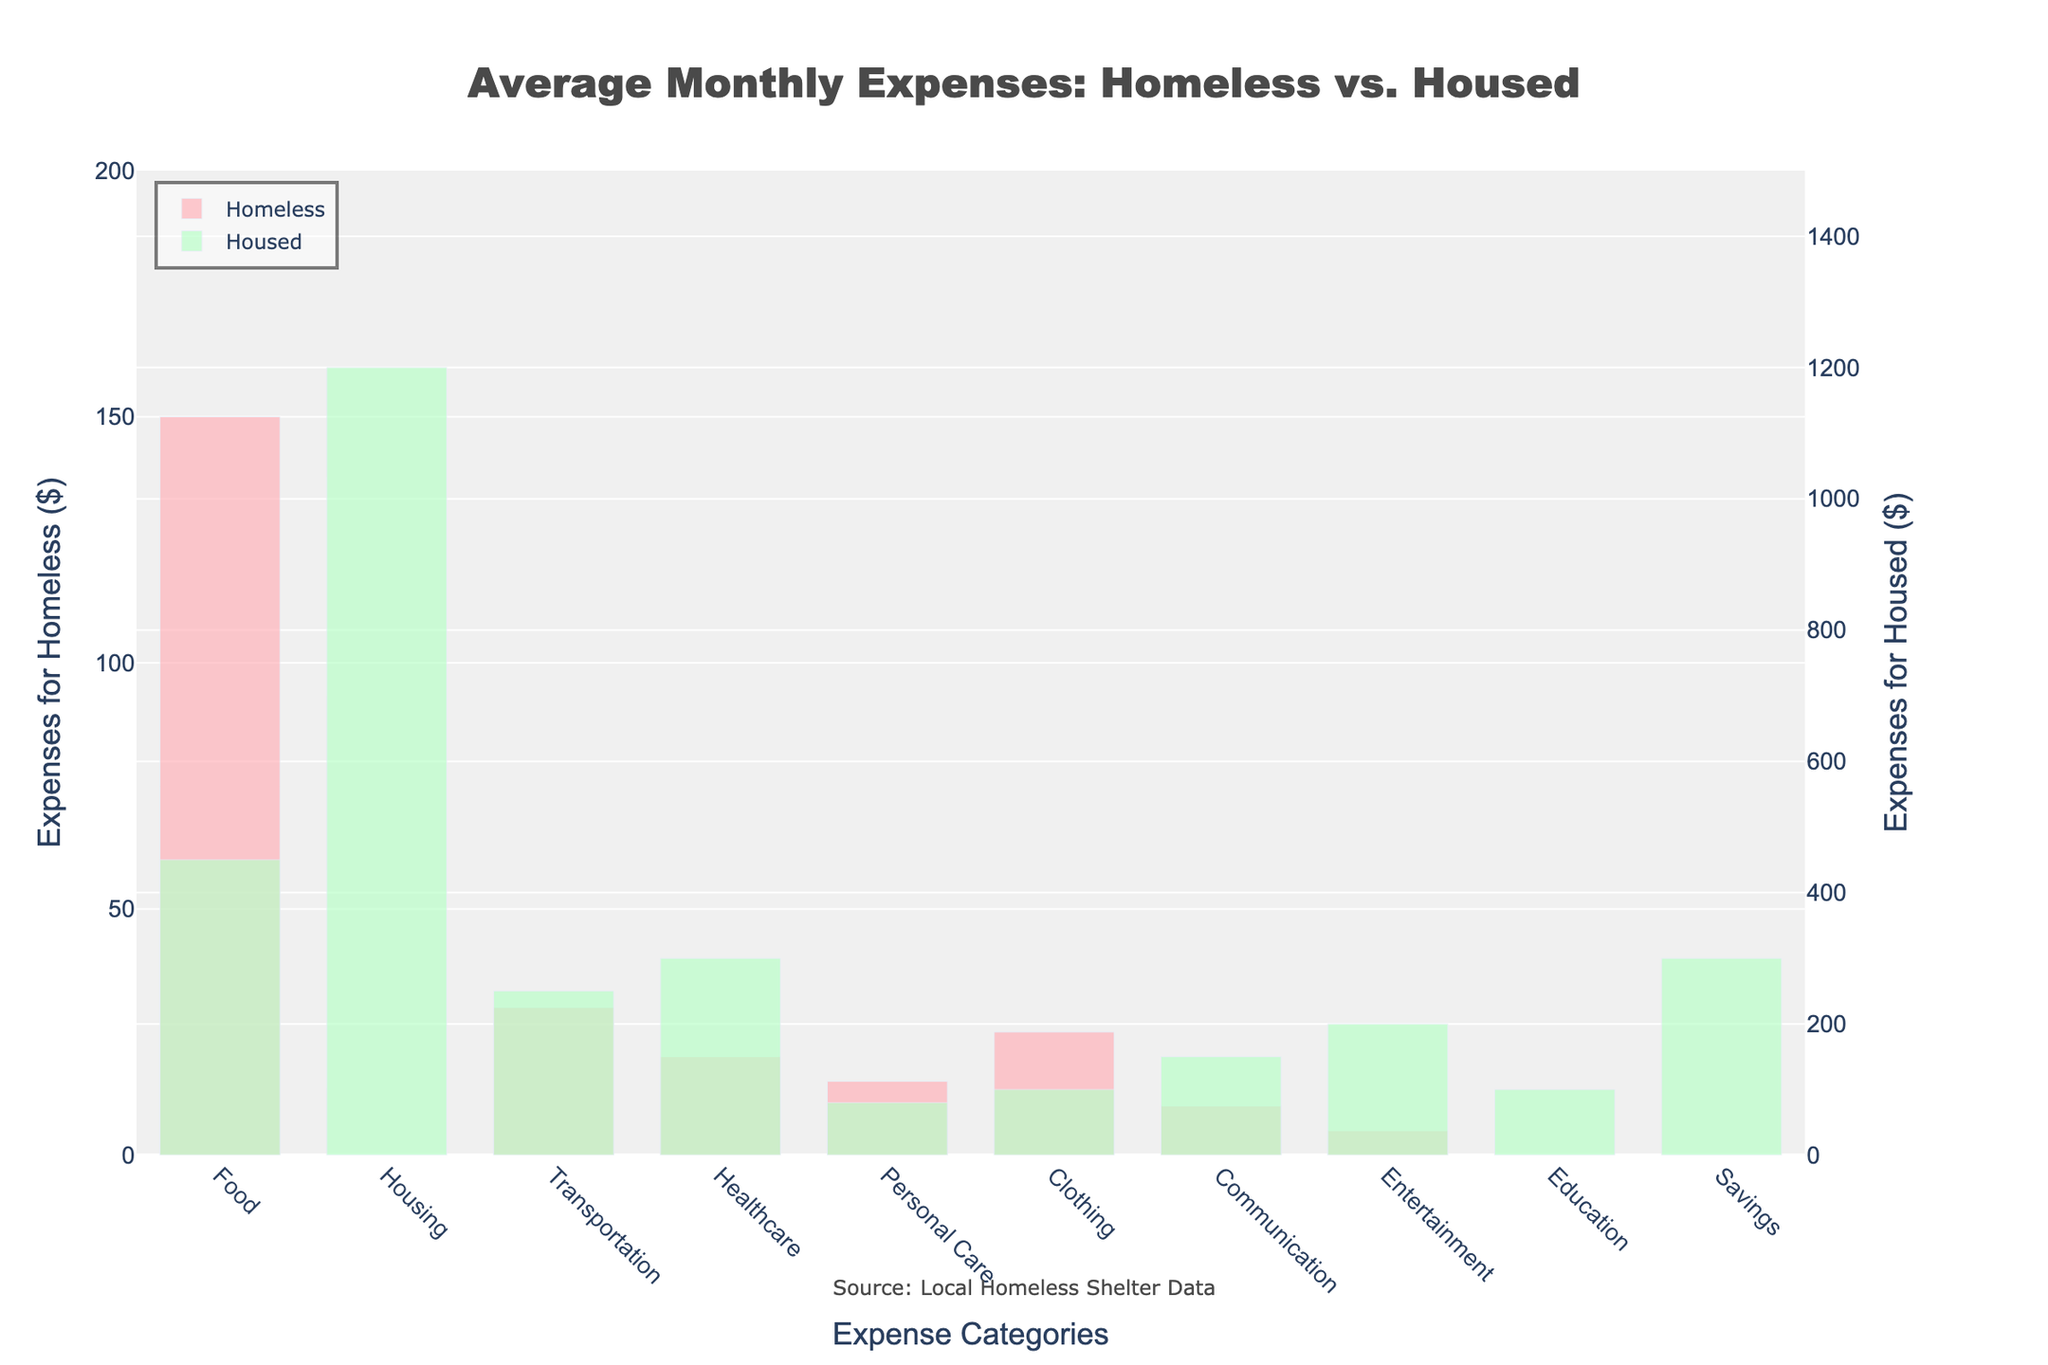What is the biggest expense difference between homeless and housed individuals in a single category? Look for the category with the largest gap between the two bars. Here, the 'Housing' category has the largest difference, with homeless individuals spending $0 and housed individuals spending $1200. The difference is $1200.
Answer: $1200 Which category has the closest expense values between homeless and housed individuals? Look for the smallest difference between the heights of the bars. The 'Personal Care' category has the smallest difference; homeless individuals spend $15 and housed individuals spend $80, making the difference $65.
Answer: Personal Care What's the total monthly expense for homeless individuals across all categories? Sum all the values under 'Homeless ($)' column. The total is 150 (Food) + 0 (Housing) + 30 (Transportation) + 20 (Healthcare) + 15 (Personal Care) + 25 (Clothing) + 10 (Communication) + 5 (Entertainment) + 0 (Education) + 0 (Savings) = 255.
Answer: $255 In which categories do homeless individuals have zero expenses? Identify the categories where the bar for 'Homeless' individuals is not present, i.e., height = 0. The categories are 'Housing', 'Education', and 'Savings'.
Answer: Housing, Education, Savings For which category is the expense for housed individuals greater than 500 dollars? Look for any bar representing 'Housed' individuals that exceeds the 500-mark on the y-axis. The 'Housing' category shows this, with housed individuals spending $1200.
Answer: Housing Which categories indicate that housed individuals spend exactly 10 times or more than homeless individuals? Evaluate whether the bar for housed individuals is 10 times or more the height of the bar for homeless individuals. The categories include 'Housing', 'Healthcare', 'Communication', 'Entertainment', and 'Education'.
Answer: Housing, Healthcare, Communication, Entertainment, Education Is there any category where homeless individuals spend more than housed individuals? Compare the heights of the bars for each category. In all cases, housed individuals' expenses are either equal or greater. No category shows homeless individuals spending more.
Answer: No Which category has the highest overall expense, considering both groups combined? Sum the expenses for both homeless and housed individuals for each category, then identify the highest. For 'Housing', the combined expense is $0 (Homeless) + $1200 (Housed) = $1200.
Answer: Housing What's the sum of expenses for housed individuals in the 'Food' and 'Healthcare' categories? Add values for housed individuals in both categories. Food is $450 and Healthcare is $300; together, they sum up to 450 + 300 = 750.
Answer: $750 